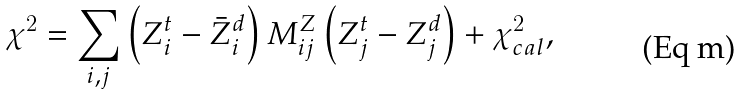Convert formula to latex. <formula><loc_0><loc_0><loc_500><loc_500>\chi ^ { 2 } = \sum _ { i , j } \left ( Z _ { i } ^ { t } - \bar { Z } _ { i } ^ { d } \right ) M _ { i j } ^ { Z } \left ( Z _ { j } ^ { t } - Z _ { j } ^ { d } \right ) + \chi ^ { 2 } _ { c a l } ,</formula> 